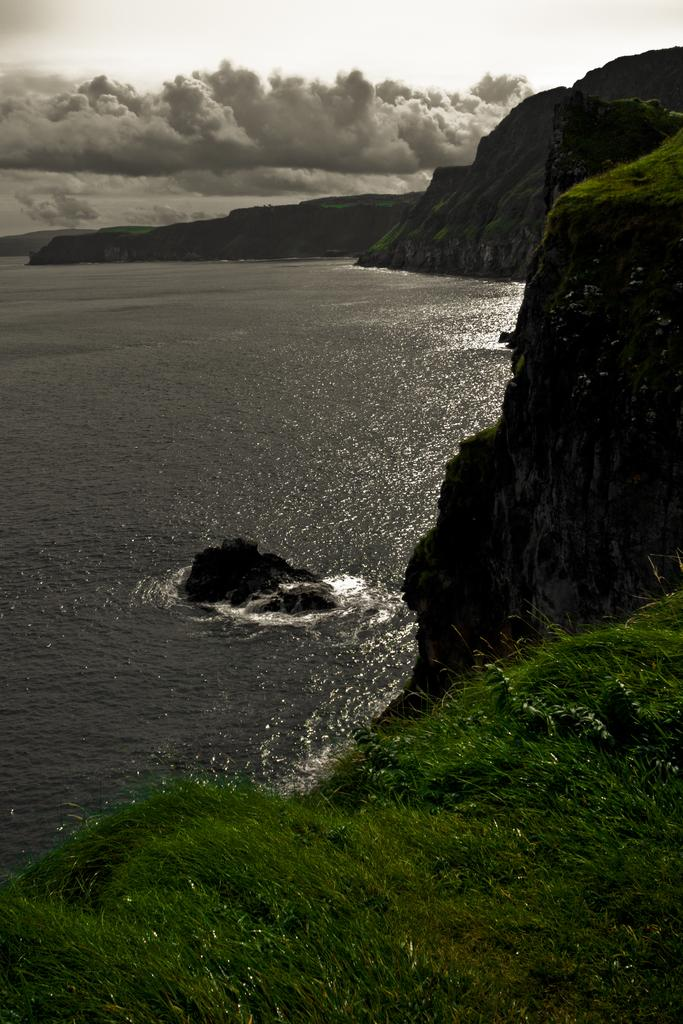What type of natural landform can be seen in the image? There are mountains in the image. What else is visible besides the mountains? There is water visible in the image. What part of the natural environment is visible in the background of the image? The sky is visible in the background of the image. Where is the cemetery located in the image? There is no cemetery present in the image. What type of animal can be seen playing with a nut in the image? There are no animals or nuts present in the image. 